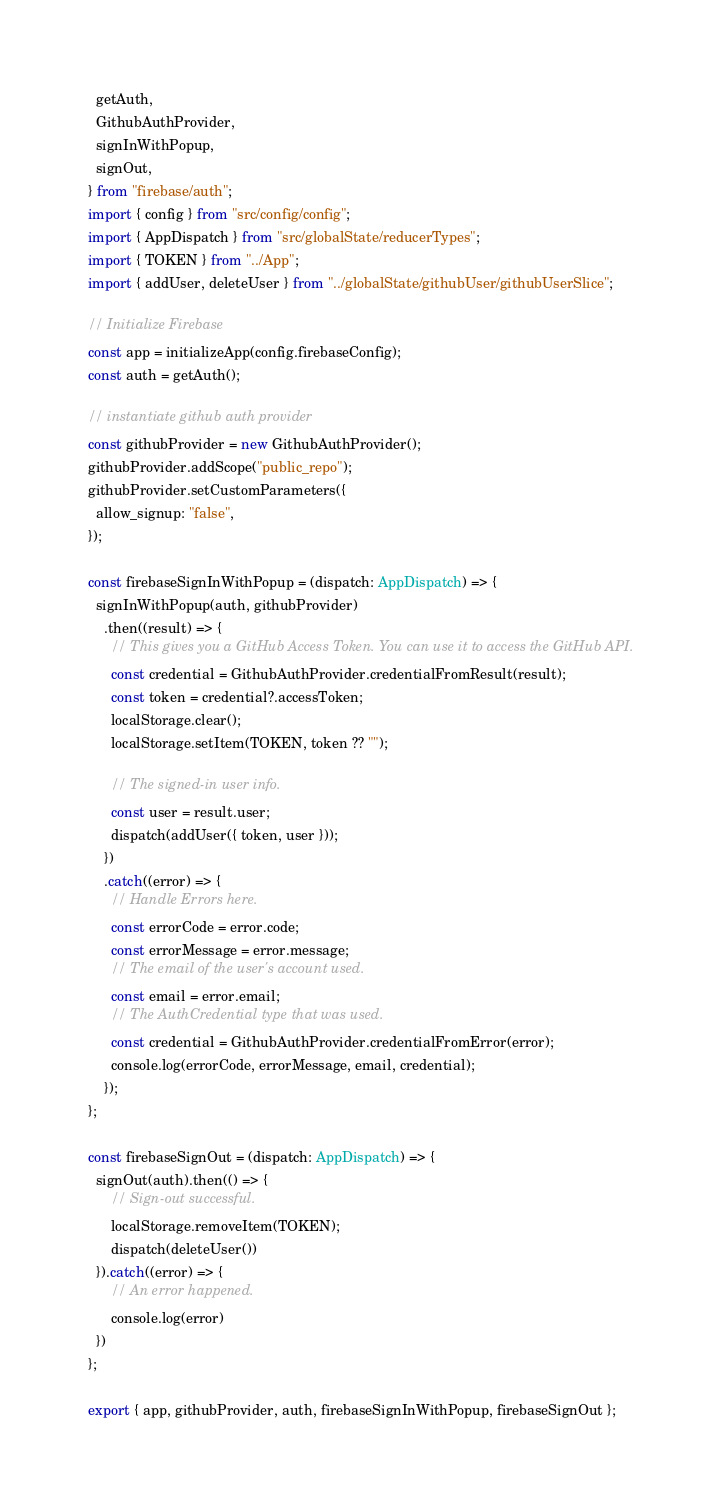<code> <loc_0><loc_0><loc_500><loc_500><_TypeScript_>  getAuth,
  GithubAuthProvider,
  signInWithPopup,
  signOut,
} from "firebase/auth";
import { config } from "src/config/config";
import { AppDispatch } from "src/globalState/reducerTypes";
import { TOKEN } from "../App";
import { addUser, deleteUser } from "../globalState/githubUser/githubUserSlice";

// Initialize Firebase
const app = initializeApp(config.firebaseConfig);
const auth = getAuth();

// instantiate github auth provider
const githubProvider = new GithubAuthProvider();
githubProvider.addScope("public_repo");
githubProvider.setCustomParameters({
  allow_signup: "false",
});

const firebaseSignInWithPopup = (dispatch: AppDispatch) => {
  signInWithPopup(auth, githubProvider)
    .then((result) => {
      // This gives you a GitHub Access Token. You can use it to access the GitHub API.
      const credential = GithubAuthProvider.credentialFromResult(result);
      const token = credential?.accessToken;
      localStorage.clear();
      localStorage.setItem(TOKEN, token ?? "");

      // The signed-in user info.
      const user = result.user;
      dispatch(addUser({ token, user }));
    })
    .catch((error) => {
      // Handle Errors here.
      const errorCode = error.code;
      const errorMessage = error.message;
      // The email of the user's account used.
      const email = error.email;
      // The AuthCredential type that was used.
      const credential = GithubAuthProvider.credentialFromError(error);
      console.log(errorCode, errorMessage, email, credential);
    });
};

const firebaseSignOut = (dispatch: AppDispatch) => {
  signOut(auth).then(() => {
      // Sign-out successful.
      localStorage.removeItem(TOKEN);
      dispatch(deleteUser())
  }).catch((error) => {
      // An error happened.
      console.log(error)
  })
};

export { app, githubProvider, auth, firebaseSignInWithPopup, firebaseSignOut };
</code> 